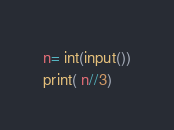<code> <loc_0><loc_0><loc_500><loc_500><_Python_>n= int(input())
print( n//3)</code> 